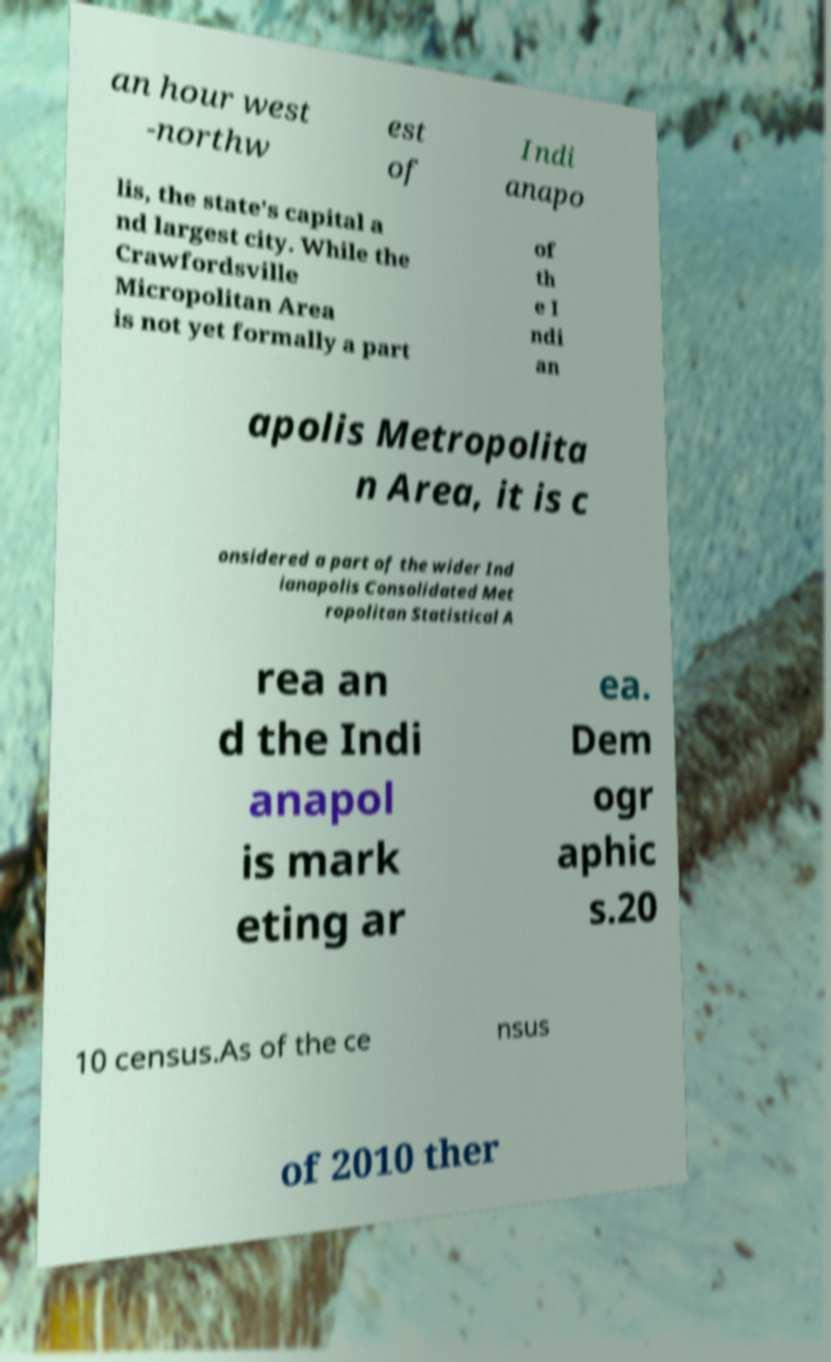Please identify and transcribe the text found in this image. an hour west -northw est of Indi anapo lis, the state's capital a nd largest city. While the Crawfordsville Micropolitan Area is not yet formally a part of th e I ndi an apolis Metropolita n Area, it is c onsidered a part of the wider Ind ianapolis Consolidated Met ropolitan Statistical A rea an d the Indi anapol is mark eting ar ea. Dem ogr aphic s.20 10 census.As of the ce nsus of 2010 ther 